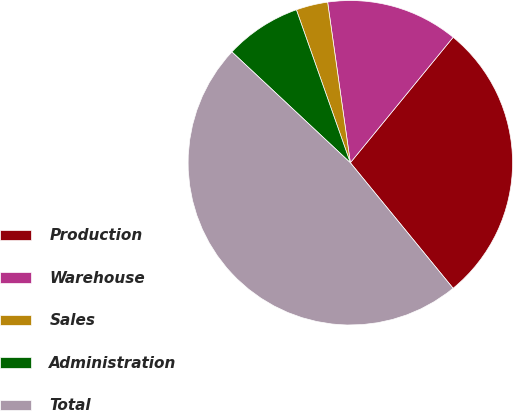<chart> <loc_0><loc_0><loc_500><loc_500><pie_chart><fcel>Production<fcel>Warehouse<fcel>Sales<fcel>Administration<fcel>Total<nl><fcel>28.16%<fcel>13.16%<fcel>3.16%<fcel>7.63%<fcel>47.89%<nl></chart> 